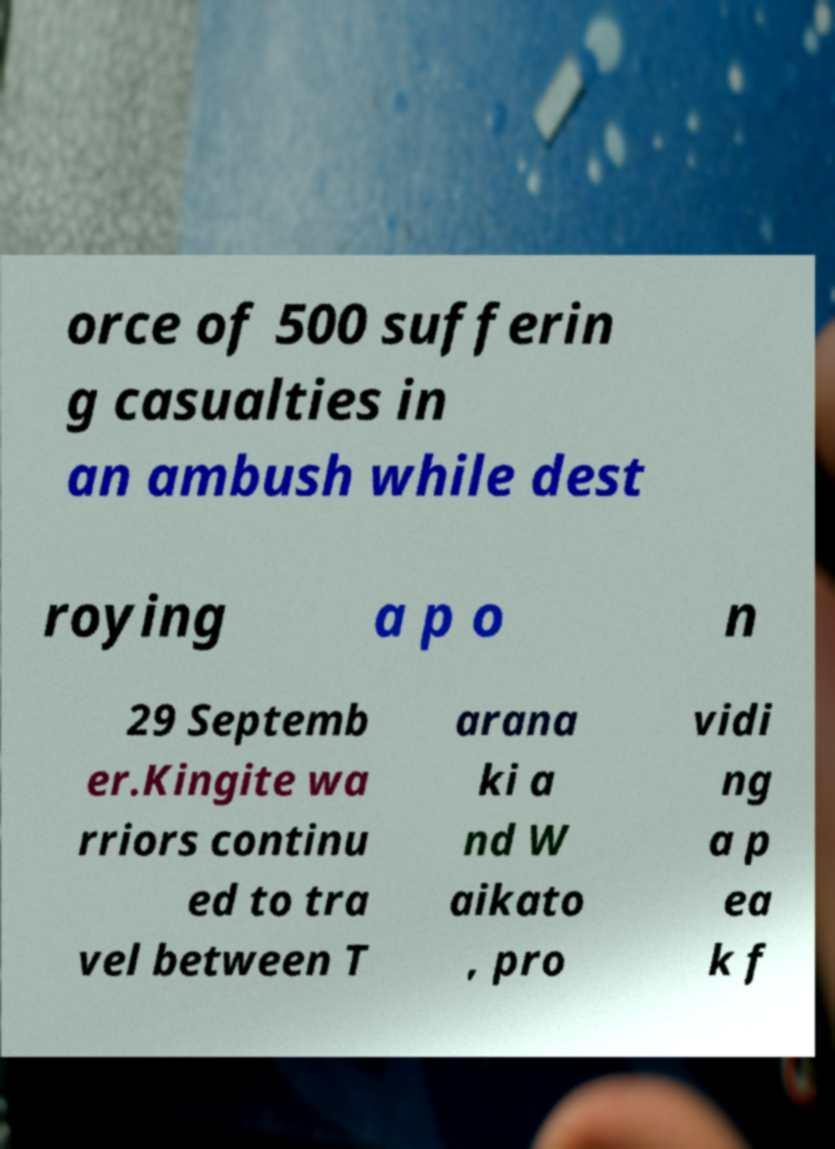Could you assist in decoding the text presented in this image and type it out clearly? orce of 500 sufferin g casualties in an ambush while dest roying a p o n 29 Septemb er.Kingite wa rriors continu ed to tra vel between T arana ki a nd W aikato , pro vidi ng a p ea k f 